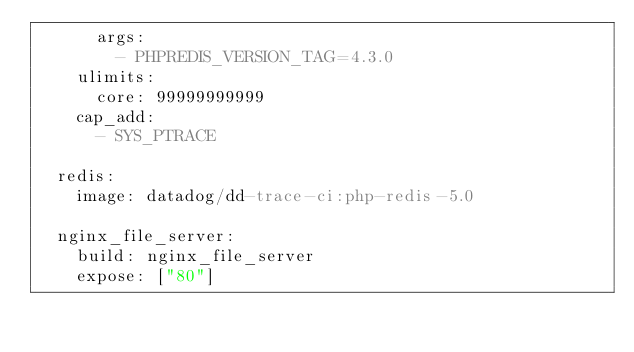<code> <loc_0><loc_0><loc_500><loc_500><_YAML_>      args:
        - PHPREDIS_VERSION_TAG=4.3.0
    ulimits:
      core: 99999999999
    cap_add:
      - SYS_PTRACE

  redis:
    image: datadog/dd-trace-ci:php-redis-5.0

  nginx_file_server:
    build: nginx_file_server
    expose: ["80"]
</code> 